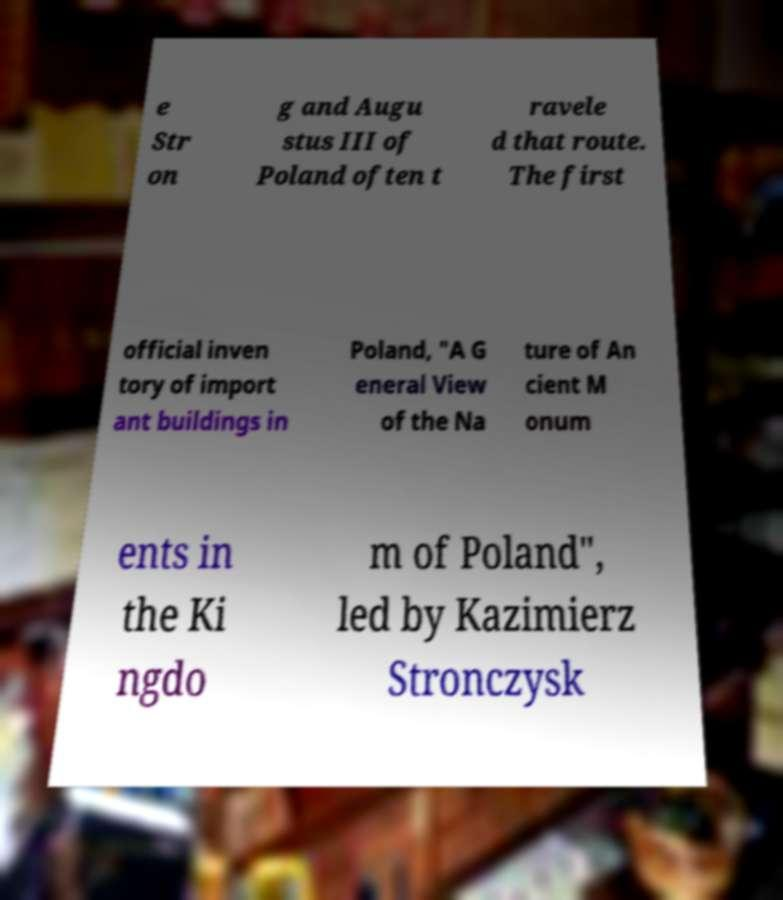For documentation purposes, I need the text within this image transcribed. Could you provide that? e Str on g and Augu stus III of Poland often t ravele d that route. The first official inven tory of import ant buildings in Poland, "A G eneral View of the Na ture of An cient M onum ents in the Ki ngdo m of Poland", led by Kazimierz Stronczysk 